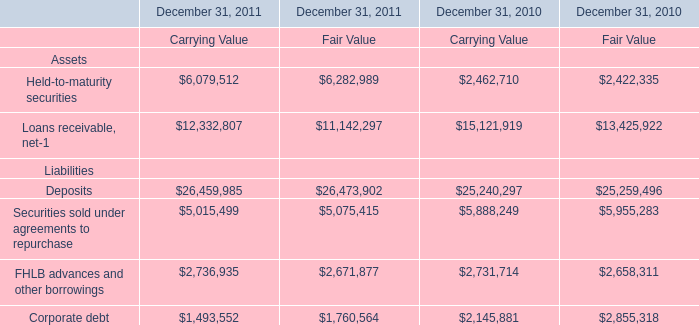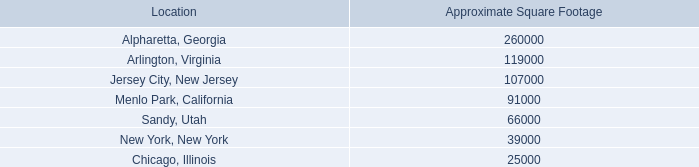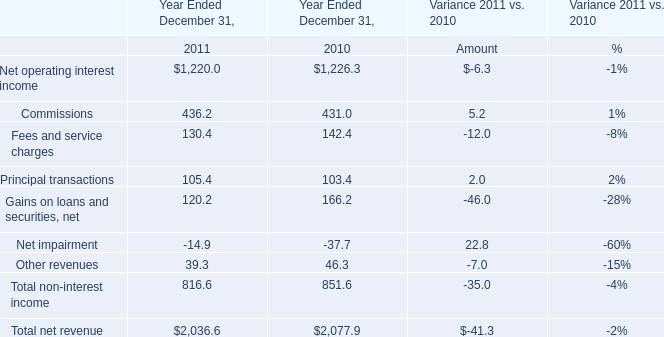What's the sum of Deposits Liabilities of December 31, 2011 Fair Value, Chicago, Illinois of Approximate Square Footage, and Corporate debt Liabilities of December 31, 2011 Carrying Value ? 
Computations: ((26473902.0 + 25000.0) + 1493552.0)
Answer: 27992454.0. 